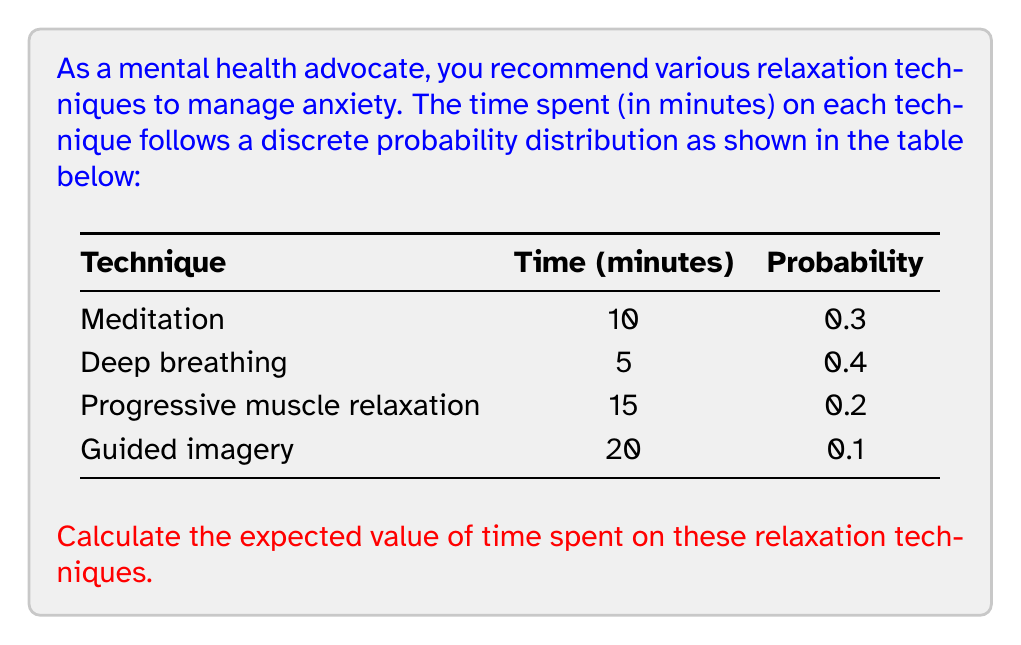Show me your answer to this math problem. To calculate the expected value of a discrete random variable, we use the formula:

$$ E(X) = \sum_{i=1}^{n} x_i \cdot p(x_i) $$

Where $x_i$ is each possible value of the random variable, and $p(x_i)$ is the probability of that value occurring.

Let's calculate for each technique:

1. Meditation: $10 \cdot 0.3 = 3$ minutes
2. Deep breathing: $5 \cdot 0.4 = 2$ minutes
3. Progressive muscle relaxation: $15 \cdot 0.2 = 3$ minutes
4. Guided imagery: $20 \cdot 0.1 = 2$ minutes

Now, we sum these values:

$$ E(X) = 3 + 2 + 3 + 2 = 10 $$

Therefore, the expected value of time spent on these relaxation techniques is 10 minutes.
Answer: 10 minutes 